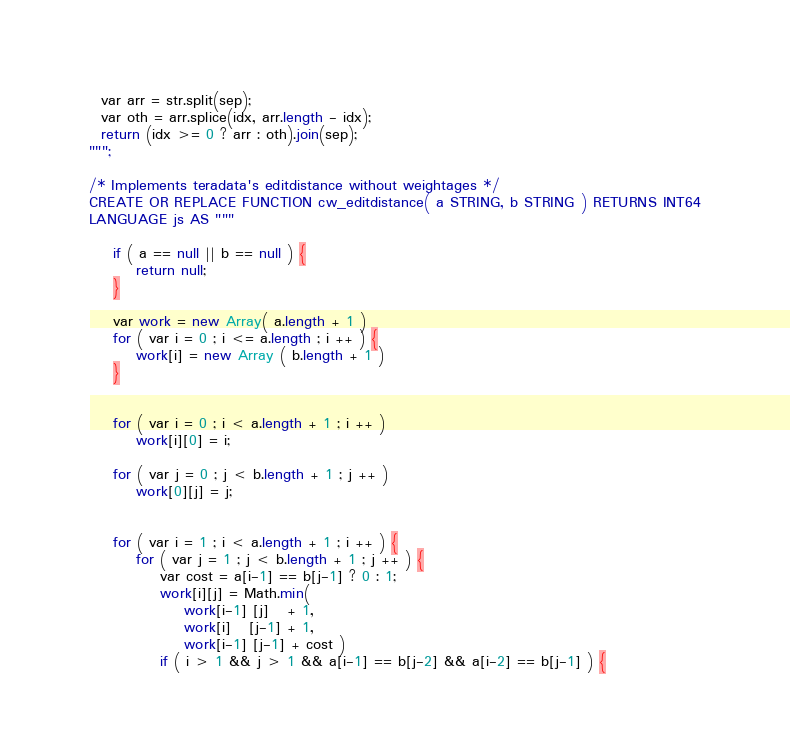<code> <loc_0><loc_0><loc_500><loc_500><_SQL_>  var arr = str.split(sep);
  var oth = arr.splice(idx, arr.length - idx);
  return (idx >= 0 ? arr : oth).join(sep);
""";

/* Implements teradata's editdistance without weightages */
CREATE OR REPLACE FUNCTION cw_editdistance( a STRING, b STRING ) RETURNS INT64
LANGUAGE js AS """

    if ( a == null || b == null ) {
        return null;
    }

    var work = new Array( a.length + 1 )
    for ( var i = 0 ; i <= a.length ; i ++ ) {
        work[i] = new Array ( b.length + 1 )
    }


    for ( var i = 0 ; i < a.length + 1 ; i ++ )
        work[i][0] = i;

    for ( var j = 0 ; j < b.length + 1 ; j ++ )
        work[0][j] = j;


    for ( var i = 1 ; i < a.length + 1 ; i ++ ) {
        for ( var j = 1 ; j < b.length + 1 ; j ++ ) {
            var cost = a[i-1] == b[j-1] ? 0 : 1;
            work[i][j] = Math.min(
                work[i-1] [j]   + 1,
                work[i]   [j-1] + 1,
                work[i-1] [j-1] + cost )
            if ( i > 1 && j > 1 && a[i-1] == b[j-2] && a[i-2] == b[j-1] ) {</code> 